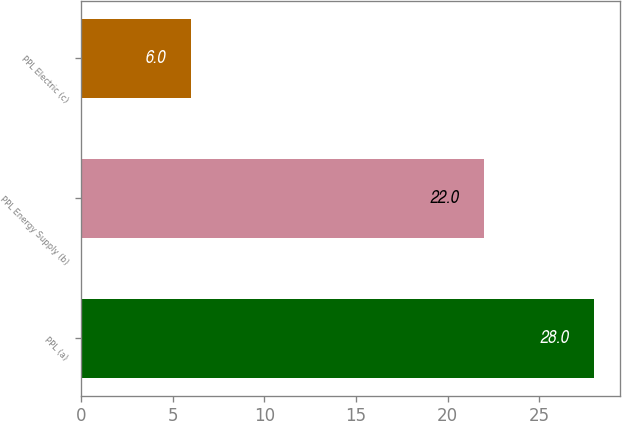Convert chart to OTSL. <chart><loc_0><loc_0><loc_500><loc_500><bar_chart><fcel>PPL (a)<fcel>PPL Energy Supply (b)<fcel>PPL Electric (c)<nl><fcel>28<fcel>22<fcel>6<nl></chart> 